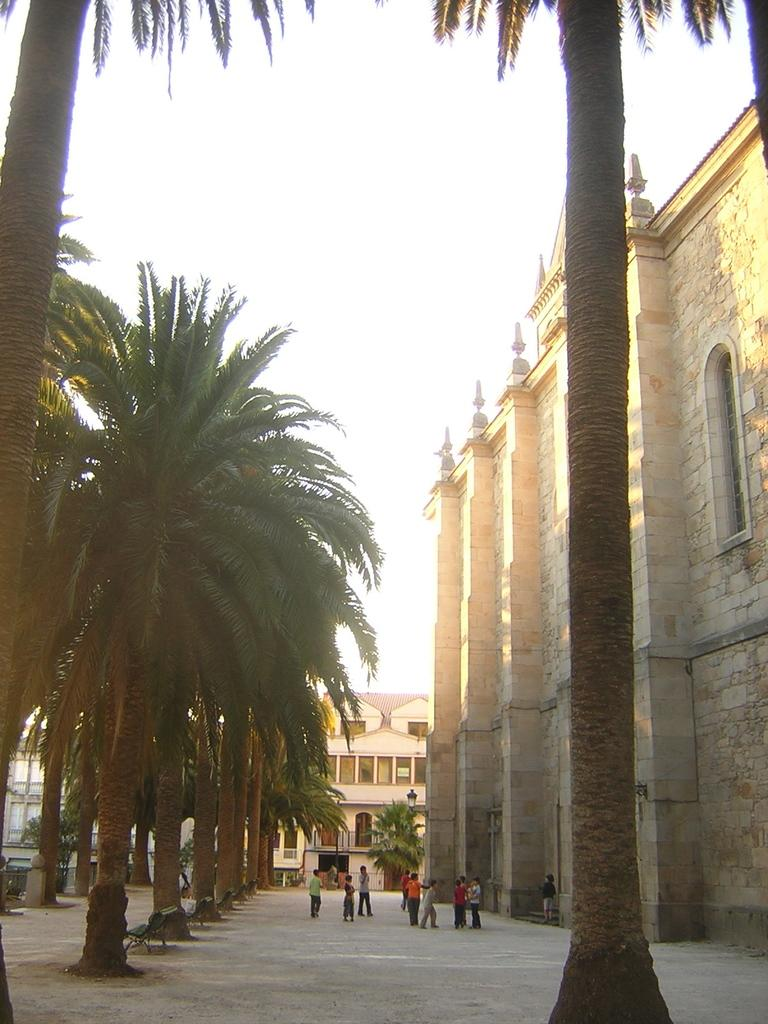What type of natural elements can be seen in the image? There are trees in the image. What are the people in the image doing? There are persons standing in the center of the image. What can be seen in the distance in the image? There are buildings and trees in the background of the image. What type of structure is located on the right side of the image? There is a castle on the right side of the image. Can you tell me how many dinosaurs are roaming around the castle in the image? There are no dinosaurs present in the image; it features a castle, trees, and people. What type of wire is used to connect the buildings in the image? There is no wire connecting the buildings in the image; the buildings are separate structures. 